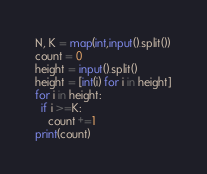<code> <loc_0><loc_0><loc_500><loc_500><_Python_>N, K = map(int,input().split())
count = 0
height = input().split()
height = [int(i) for i in height]
for i in height:
  if i >=K:
    count +=1
print(count)</code> 